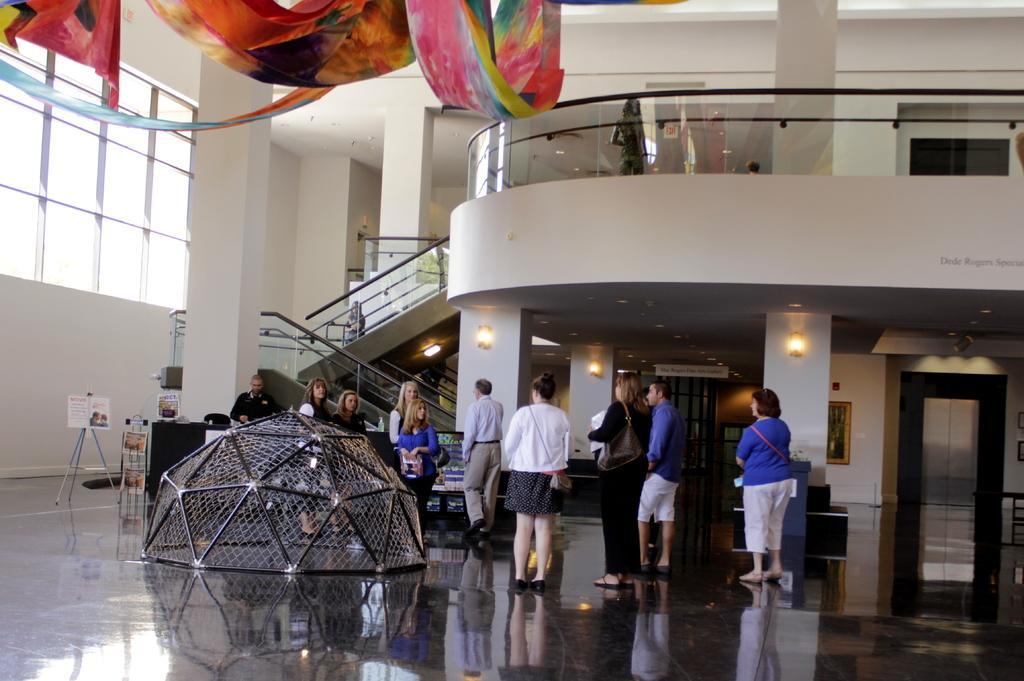Please provide a concise description of this image. In the picture we can see inside view of the building lobby with some people are standing and beside them, we can see some crafts and a stand with board near the wall and behind the people we can see some pillars with lights to each pillar and beside it we can see the steps with glass railing and on the top of it also we can see the floor with the glass railing. 